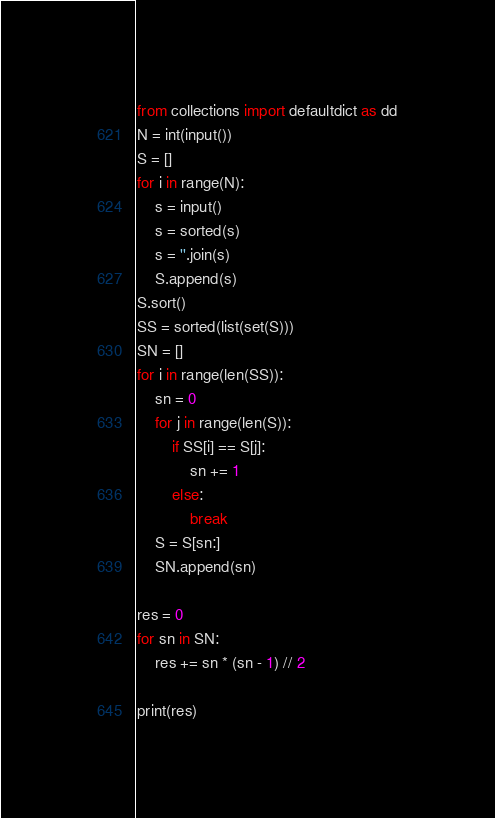Convert code to text. <code><loc_0><loc_0><loc_500><loc_500><_Python_>from collections import defaultdict as dd
N = int(input())
S = []
for i in range(N):
    s = input()
    s = sorted(s)
    s = ''.join(s)
    S.append(s)
S.sort()
SS = sorted(list(set(S)))
SN = []
for i in range(len(SS)):
    sn = 0
    for j in range(len(S)):
        if SS[i] == S[j]:
            sn += 1
        else:
            break
    S = S[sn:]
    SN.append(sn)

res = 0
for sn in SN:
    res += sn * (sn - 1) // 2

print(res)</code> 